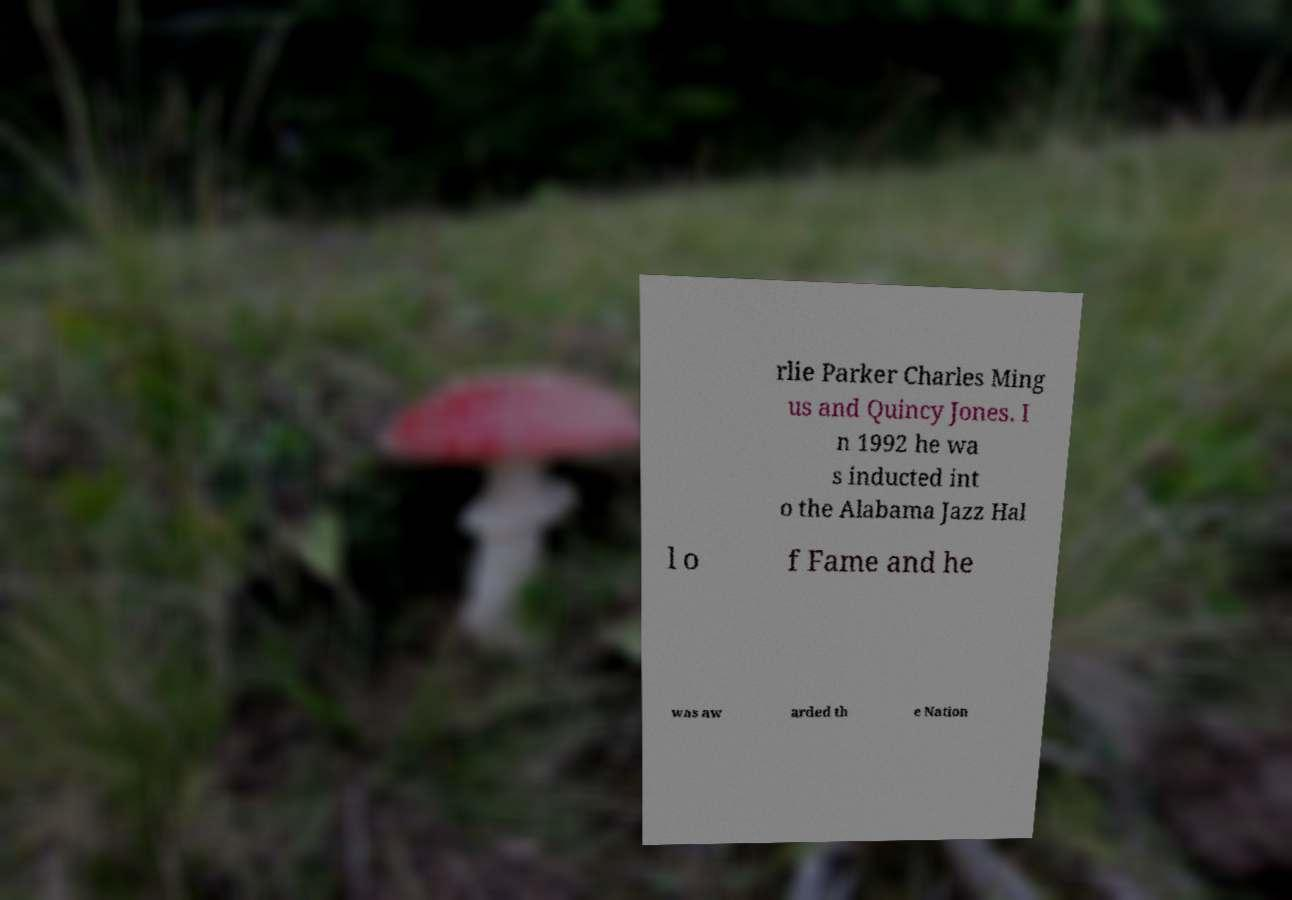I need the written content from this picture converted into text. Can you do that? rlie Parker Charles Ming us and Quincy Jones. I n 1992 he wa s inducted int o the Alabama Jazz Hal l o f Fame and he was aw arded th e Nation 